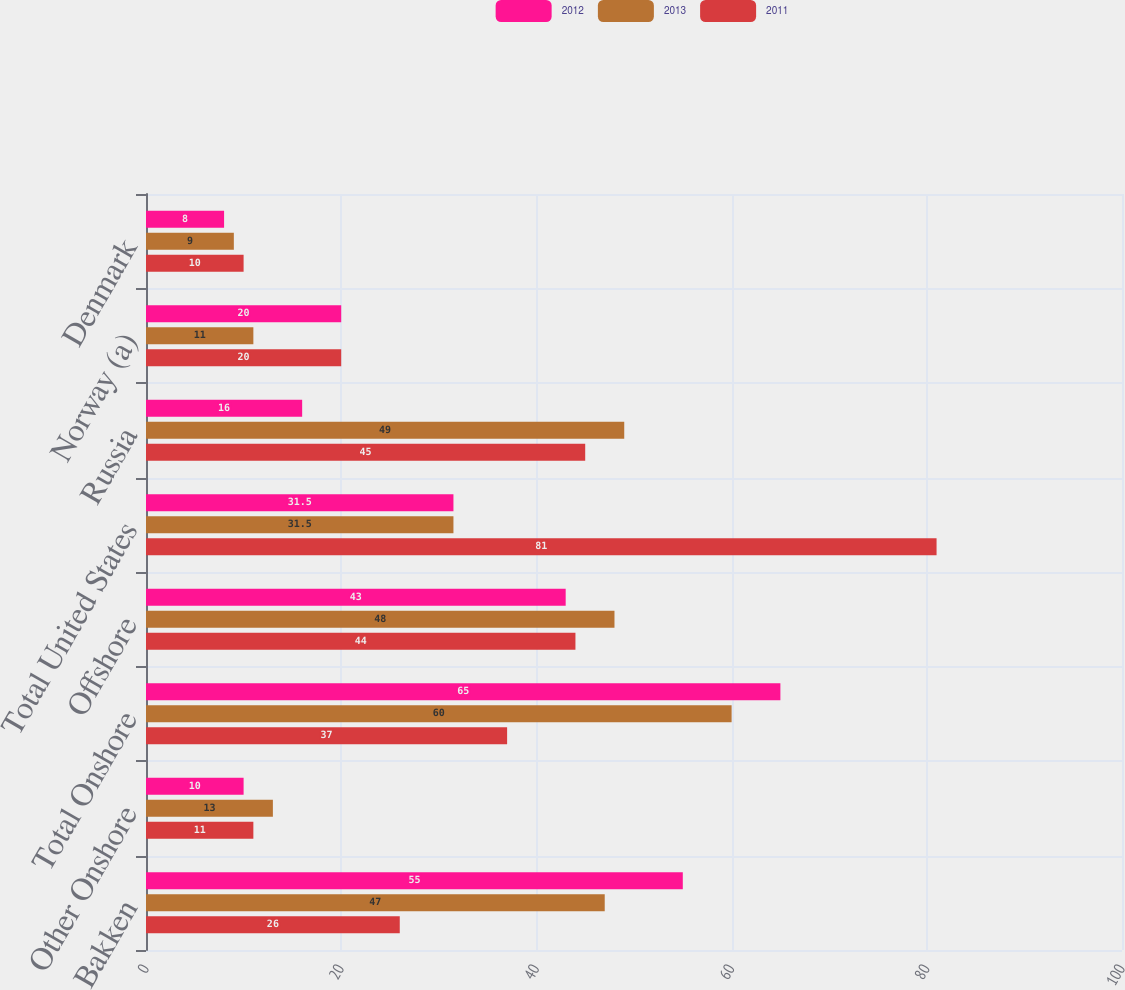Convert chart. <chart><loc_0><loc_0><loc_500><loc_500><stacked_bar_chart><ecel><fcel>Bakken<fcel>Other Onshore<fcel>Total Onshore<fcel>Offshore<fcel>Total United States<fcel>Russia<fcel>Norway (a)<fcel>Denmark<nl><fcel>2012<fcel>55<fcel>10<fcel>65<fcel>43<fcel>31.5<fcel>16<fcel>20<fcel>8<nl><fcel>2013<fcel>47<fcel>13<fcel>60<fcel>48<fcel>31.5<fcel>49<fcel>11<fcel>9<nl><fcel>2011<fcel>26<fcel>11<fcel>37<fcel>44<fcel>81<fcel>45<fcel>20<fcel>10<nl></chart> 